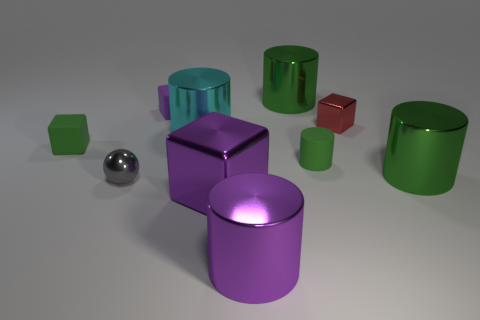Are there any other things that have the same shape as the gray object?
Provide a short and direct response. No. What is the color of the small block that is the same material as the purple cylinder?
Provide a succinct answer. Red. Is there a small green matte thing that is on the right side of the tiny rubber cube that is on the right side of the small gray metal object?
Make the answer very short. Yes. How many other things are the same shape as the big cyan shiny thing?
Provide a short and direct response. 4. Is the shape of the purple thing behind the gray shiny sphere the same as the green rubber thing that is on the left side of the purple cylinder?
Provide a short and direct response. Yes. There is a tiny matte cube right of the metallic ball left of the big purple cylinder; what number of small purple rubber objects are right of it?
Offer a terse response. 0. What color is the small cylinder?
Ensure brevity in your answer.  Green. What number of other objects are the same size as the purple metallic block?
Offer a terse response. 4. What material is the large purple thing that is the same shape as the cyan thing?
Your response must be concise. Metal. The large object that is on the right side of the green metal object behind the big cyan thing behind the green block is made of what material?
Your answer should be very brief. Metal. 